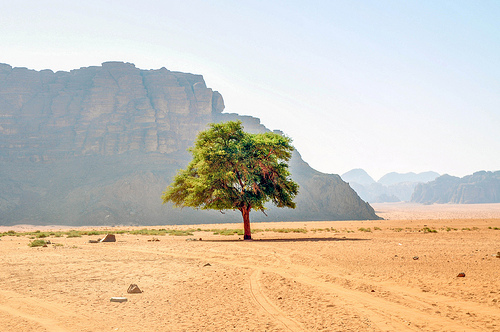<image>
Is the tree to the left of the mountain? No. The tree is not to the left of the mountain. From this viewpoint, they have a different horizontal relationship. Where is the tree in relation to the mountain? Is it next to the mountain? Yes. The tree is positioned adjacent to the mountain, located nearby in the same general area. Is the tree next to the ridge? Yes. The tree is positioned adjacent to the ridge, located nearby in the same general area. 